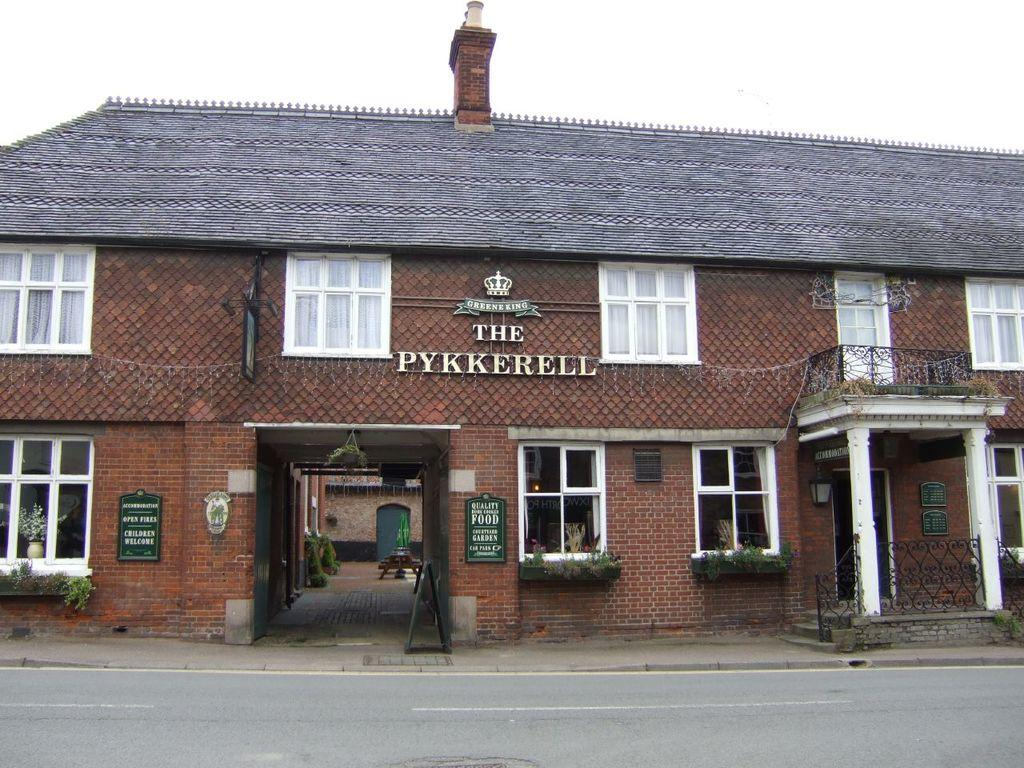What is located at the bottom of the image? There is a road at the bottom of the image. What can be seen in the background of the image? There is a building in the background of the image. What features does the building have? The building has windows and a roof. What is visible in the sky in the image? There are clouds in the sky. Can you tell me how many light bulbs are hanging from the roof of the building in the image? There is no mention of light bulbs in the image; the building has windows and a roof, but no bulbs are visible. What type of jelly can be seen on the road in the image? There is no jelly present on the road in the image; it only shows a road at the bottom. 